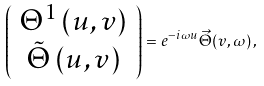<formula> <loc_0><loc_0><loc_500><loc_500>\left ( \begin{array} { c } \Theta ^ { 1 } \left ( u , v \right ) \\ \tilde { \Theta } \left ( u , v \right ) \end{array} \right ) = e ^ { - i \omega u } \vec { \Theta } ( v , \omega ) \, ,</formula> 